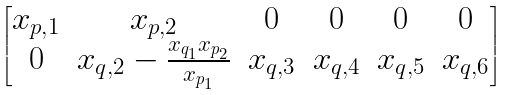<formula> <loc_0><loc_0><loc_500><loc_500>\begin{bmatrix} x _ { p , 1 } & x _ { p , 2 } & 0 & 0 & 0 & 0 \\ 0 & x _ { q , 2 } - \frac { x _ { q _ { 1 } } x _ { p _ { 2 } } } { x _ { p _ { 1 } } } & x _ { q , 3 } & x _ { q , 4 } & x _ { q , 5 } & x _ { q , 6 } \end{bmatrix}</formula> 